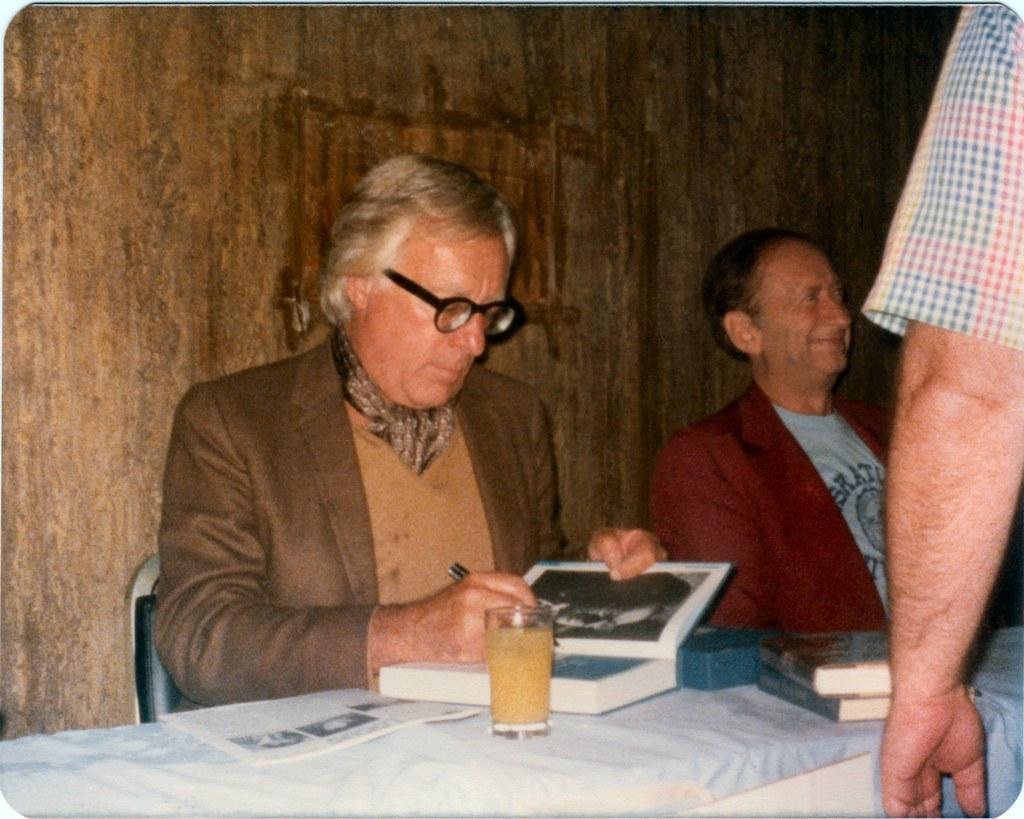Please provide a concise description of this image. On the right there is a person's hand. In the center of the picture there is a table, on the table there are books, glass. In the center of the picture there are two persons sitting in chairs, behind them it is wall. 